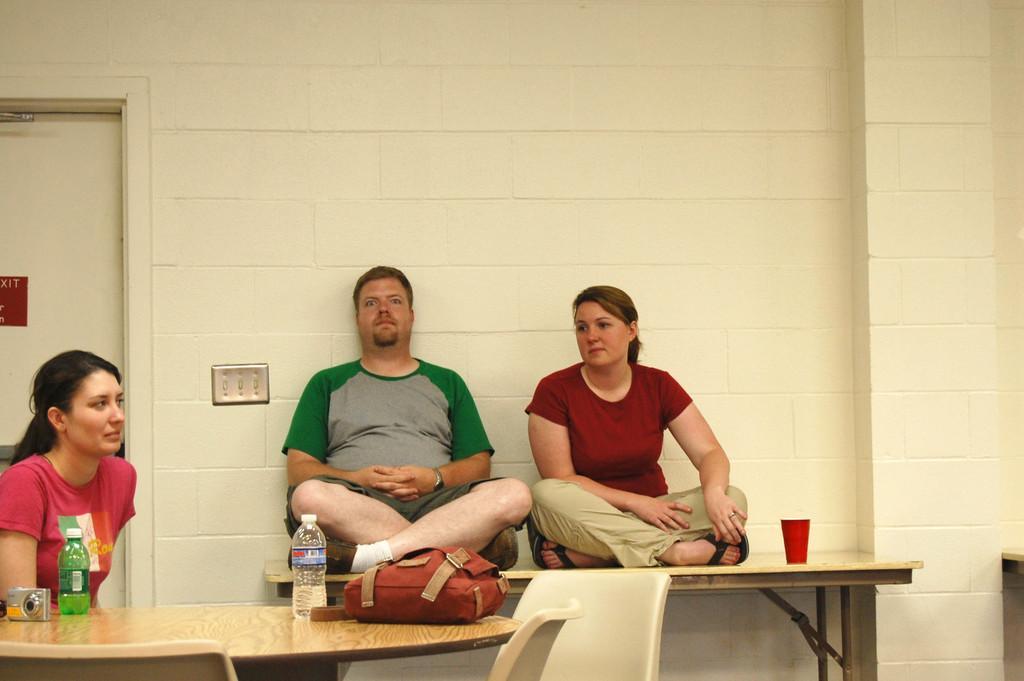Please provide a concise description of this image. In this image I see 3 persons and 2 of them are women and another one is a man and all of them are sitting and there is a table over here and there are 2 bottles, a bag and a camera. In the background I can see a door and the wall. 